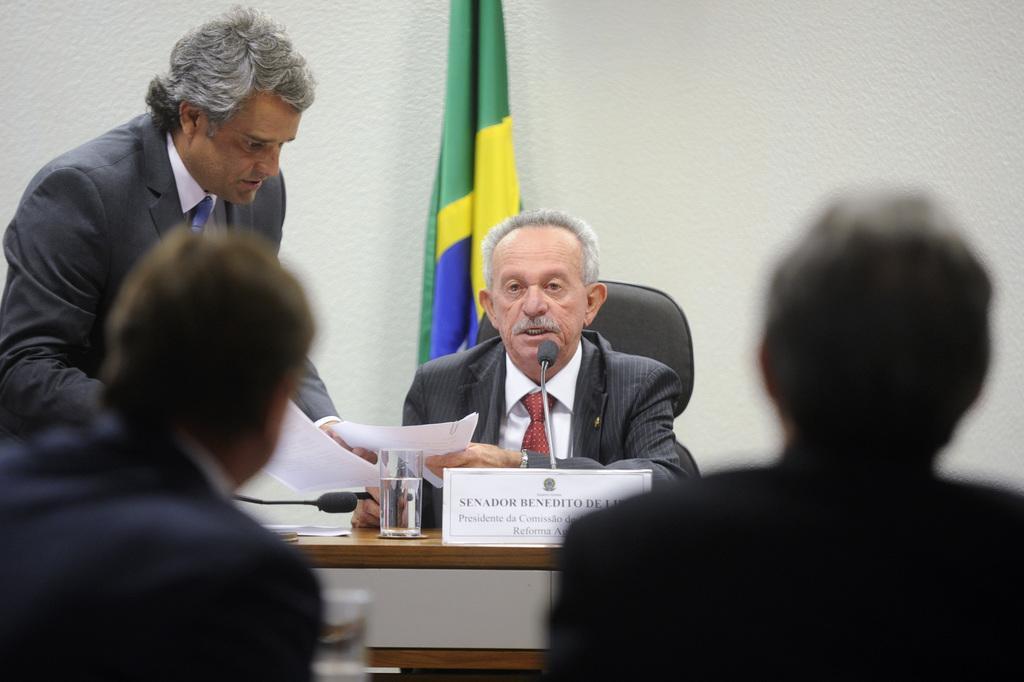How would you summarize this image in a sentence or two? In the picture we can see for people, one man is sitting near the desk and two men are sitting opposite to him and one man is standing beside them and giving some papers to him and on the desk, we can see a glass of water, name board and in the background we can see the flag and the wall. 